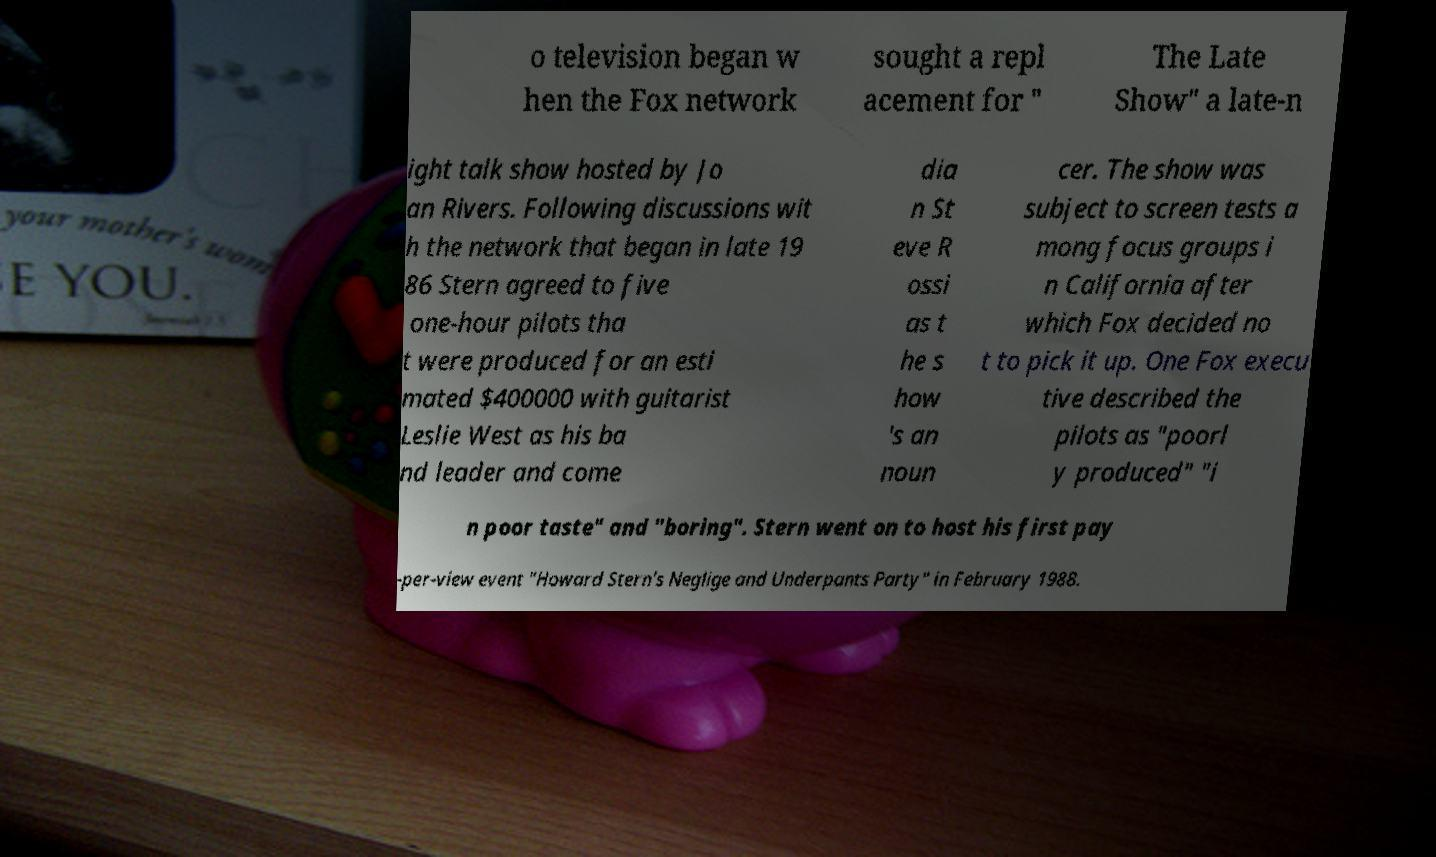I need the written content from this picture converted into text. Can you do that? o television began w hen the Fox network sought a repl acement for " The Late Show" a late-n ight talk show hosted by Jo an Rivers. Following discussions wit h the network that began in late 19 86 Stern agreed to five one-hour pilots tha t were produced for an esti mated $400000 with guitarist Leslie West as his ba nd leader and come dia n St eve R ossi as t he s how 's an noun cer. The show was subject to screen tests a mong focus groups i n California after which Fox decided no t to pick it up. One Fox execu tive described the pilots as "poorl y produced" "i n poor taste" and "boring". Stern went on to host his first pay -per-view event "Howard Stern's Neglige and Underpants Party" in February 1988. 